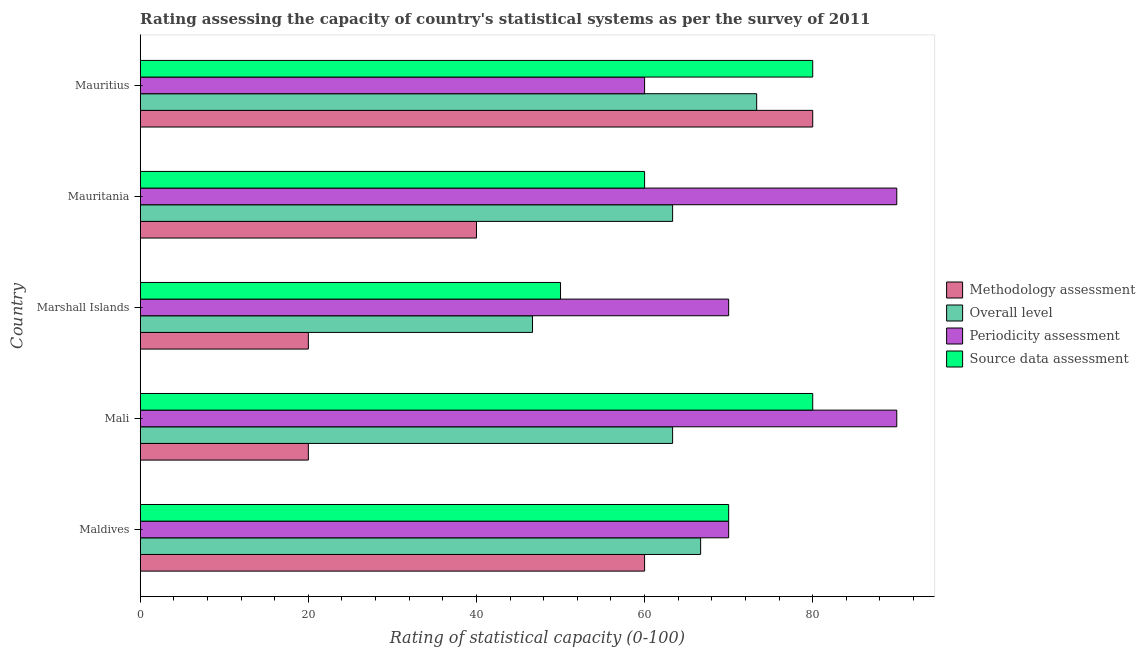How many different coloured bars are there?
Your answer should be very brief. 4. How many groups of bars are there?
Your answer should be compact. 5. Are the number of bars on each tick of the Y-axis equal?
Ensure brevity in your answer.  Yes. How many bars are there on the 4th tick from the top?
Your response must be concise. 4. How many bars are there on the 2nd tick from the bottom?
Keep it short and to the point. 4. What is the label of the 4th group of bars from the top?
Provide a short and direct response. Mali. What is the overall level rating in Maldives?
Ensure brevity in your answer.  66.67. Across all countries, what is the maximum periodicity assessment rating?
Ensure brevity in your answer.  90. Across all countries, what is the minimum periodicity assessment rating?
Your answer should be compact. 60. In which country was the overall level rating maximum?
Give a very brief answer. Mauritius. In which country was the source data assessment rating minimum?
Keep it short and to the point. Marshall Islands. What is the total source data assessment rating in the graph?
Keep it short and to the point. 340. What is the difference between the source data assessment rating in Mali and that in Mauritania?
Your answer should be compact. 20. What is the difference between the periodicity assessment rating in Mauritania and the overall level rating in Marshall Islands?
Give a very brief answer. 43.33. What is the difference between the source data assessment rating and overall level rating in Mauritania?
Ensure brevity in your answer.  -3.33. Is the difference between the methodology assessment rating in Mauritania and Mauritius greater than the difference between the overall level rating in Mauritania and Mauritius?
Offer a very short reply. No. What is the difference between the highest and the second highest source data assessment rating?
Ensure brevity in your answer.  0. What is the difference between the highest and the lowest source data assessment rating?
Give a very brief answer. 30. In how many countries, is the source data assessment rating greater than the average source data assessment rating taken over all countries?
Your answer should be very brief. 3. Is the sum of the source data assessment rating in Maldives and Mauritania greater than the maximum methodology assessment rating across all countries?
Offer a terse response. Yes. Is it the case that in every country, the sum of the overall level rating and periodicity assessment rating is greater than the sum of methodology assessment rating and source data assessment rating?
Your answer should be compact. No. What does the 2nd bar from the top in Mauritania represents?
Offer a very short reply. Periodicity assessment. What does the 2nd bar from the bottom in Maldives represents?
Give a very brief answer. Overall level. How many bars are there?
Provide a succinct answer. 20. Are all the bars in the graph horizontal?
Ensure brevity in your answer.  Yes. How many countries are there in the graph?
Your answer should be very brief. 5. What is the difference between two consecutive major ticks on the X-axis?
Provide a succinct answer. 20. Are the values on the major ticks of X-axis written in scientific E-notation?
Give a very brief answer. No. How many legend labels are there?
Ensure brevity in your answer.  4. How are the legend labels stacked?
Ensure brevity in your answer.  Vertical. What is the title of the graph?
Your answer should be compact. Rating assessing the capacity of country's statistical systems as per the survey of 2011 . Does "Primary" appear as one of the legend labels in the graph?
Offer a terse response. No. What is the label or title of the X-axis?
Make the answer very short. Rating of statistical capacity (0-100). What is the label or title of the Y-axis?
Make the answer very short. Country. What is the Rating of statistical capacity (0-100) of Methodology assessment in Maldives?
Offer a very short reply. 60. What is the Rating of statistical capacity (0-100) in Overall level in Maldives?
Your answer should be very brief. 66.67. What is the Rating of statistical capacity (0-100) in Periodicity assessment in Maldives?
Keep it short and to the point. 70. What is the Rating of statistical capacity (0-100) in Overall level in Mali?
Your answer should be very brief. 63.33. What is the Rating of statistical capacity (0-100) in Periodicity assessment in Mali?
Offer a terse response. 90. What is the Rating of statistical capacity (0-100) of Overall level in Marshall Islands?
Ensure brevity in your answer.  46.67. What is the Rating of statistical capacity (0-100) of Source data assessment in Marshall Islands?
Make the answer very short. 50. What is the Rating of statistical capacity (0-100) of Overall level in Mauritania?
Your answer should be compact. 63.33. What is the Rating of statistical capacity (0-100) of Methodology assessment in Mauritius?
Your response must be concise. 80. What is the Rating of statistical capacity (0-100) of Overall level in Mauritius?
Give a very brief answer. 73.33. What is the Rating of statistical capacity (0-100) in Periodicity assessment in Mauritius?
Your answer should be very brief. 60. What is the Rating of statistical capacity (0-100) of Source data assessment in Mauritius?
Your answer should be very brief. 80. Across all countries, what is the maximum Rating of statistical capacity (0-100) of Methodology assessment?
Give a very brief answer. 80. Across all countries, what is the maximum Rating of statistical capacity (0-100) of Overall level?
Your answer should be compact. 73.33. Across all countries, what is the minimum Rating of statistical capacity (0-100) in Overall level?
Offer a terse response. 46.67. What is the total Rating of statistical capacity (0-100) of Methodology assessment in the graph?
Give a very brief answer. 220. What is the total Rating of statistical capacity (0-100) in Overall level in the graph?
Provide a short and direct response. 313.33. What is the total Rating of statistical capacity (0-100) of Periodicity assessment in the graph?
Offer a very short reply. 380. What is the total Rating of statistical capacity (0-100) of Source data assessment in the graph?
Provide a succinct answer. 340. What is the difference between the Rating of statistical capacity (0-100) of Methodology assessment in Maldives and that in Mali?
Give a very brief answer. 40. What is the difference between the Rating of statistical capacity (0-100) of Periodicity assessment in Maldives and that in Mali?
Your answer should be very brief. -20. What is the difference between the Rating of statistical capacity (0-100) of Source data assessment in Maldives and that in Mali?
Keep it short and to the point. -10. What is the difference between the Rating of statistical capacity (0-100) of Overall level in Maldives and that in Mauritania?
Provide a short and direct response. 3.33. What is the difference between the Rating of statistical capacity (0-100) in Source data assessment in Maldives and that in Mauritania?
Your response must be concise. 10. What is the difference between the Rating of statistical capacity (0-100) in Overall level in Maldives and that in Mauritius?
Make the answer very short. -6.67. What is the difference between the Rating of statistical capacity (0-100) in Source data assessment in Maldives and that in Mauritius?
Your answer should be very brief. -10. What is the difference between the Rating of statistical capacity (0-100) in Overall level in Mali and that in Marshall Islands?
Provide a short and direct response. 16.67. What is the difference between the Rating of statistical capacity (0-100) of Source data assessment in Mali and that in Marshall Islands?
Give a very brief answer. 30. What is the difference between the Rating of statistical capacity (0-100) in Source data assessment in Mali and that in Mauritania?
Your answer should be compact. 20. What is the difference between the Rating of statistical capacity (0-100) of Methodology assessment in Mali and that in Mauritius?
Offer a very short reply. -60. What is the difference between the Rating of statistical capacity (0-100) of Overall level in Mali and that in Mauritius?
Make the answer very short. -10. What is the difference between the Rating of statistical capacity (0-100) in Methodology assessment in Marshall Islands and that in Mauritania?
Make the answer very short. -20. What is the difference between the Rating of statistical capacity (0-100) of Overall level in Marshall Islands and that in Mauritania?
Your answer should be compact. -16.67. What is the difference between the Rating of statistical capacity (0-100) of Source data assessment in Marshall Islands and that in Mauritania?
Give a very brief answer. -10. What is the difference between the Rating of statistical capacity (0-100) in Methodology assessment in Marshall Islands and that in Mauritius?
Offer a terse response. -60. What is the difference between the Rating of statistical capacity (0-100) of Overall level in Marshall Islands and that in Mauritius?
Offer a terse response. -26.67. What is the difference between the Rating of statistical capacity (0-100) of Source data assessment in Mauritania and that in Mauritius?
Your answer should be very brief. -20. What is the difference between the Rating of statistical capacity (0-100) of Methodology assessment in Maldives and the Rating of statistical capacity (0-100) of Periodicity assessment in Mali?
Keep it short and to the point. -30. What is the difference between the Rating of statistical capacity (0-100) of Methodology assessment in Maldives and the Rating of statistical capacity (0-100) of Source data assessment in Mali?
Make the answer very short. -20. What is the difference between the Rating of statistical capacity (0-100) of Overall level in Maldives and the Rating of statistical capacity (0-100) of Periodicity assessment in Mali?
Your response must be concise. -23.33. What is the difference between the Rating of statistical capacity (0-100) of Overall level in Maldives and the Rating of statistical capacity (0-100) of Source data assessment in Mali?
Your response must be concise. -13.33. What is the difference between the Rating of statistical capacity (0-100) in Methodology assessment in Maldives and the Rating of statistical capacity (0-100) in Overall level in Marshall Islands?
Your response must be concise. 13.33. What is the difference between the Rating of statistical capacity (0-100) of Methodology assessment in Maldives and the Rating of statistical capacity (0-100) of Source data assessment in Marshall Islands?
Your answer should be very brief. 10. What is the difference between the Rating of statistical capacity (0-100) in Overall level in Maldives and the Rating of statistical capacity (0-100) in Periodicity assessment in Marshall Islands?
Make the answer very short. -3.33. What is the difference between the Rating of statistical capacity (0-100) in Overall level in Maldives and the Rating of statistical capacity (0-100) in Source data assessment in Marshall Islands?
Give a very brief answer. 16.67. What is the difference between the Rating of statistical capacity (0-100) of Methodology assessment in Maldives and the Rating of statistical capacity (0-100) of Overall level in Mauritania?
Provide a succinct answer. -3.33. What is the difference between the Rating of statistical capacity (0-100) of Methodology assessment in Maldives and the Rating of statistical capacity (0-100) of Periodicity assessment in Mauritania?
Provide a short and direct response. -30. What is the difference between the Rating of statistical capacity (0-100) in Methodology assessment in Maldives and the Rating of statistical capacity (0-100) in Source data assessment in Mauritania?
Offer a terse response. 0. What is the difference between the Rating of statistical capacity (0-100) of Overall level in Maldives and the Rating of statistical capacity (0-100) of Periodicity assessment in Mauritania?
Keep it short and to the point. -23.33. What is the difference between the Rating of statistical capacity (0-100) of Periodicity assessment in Maldives and the Rating of statistical capacity (0-100) of Source data assessment in Mauritania?
Offer a terse response. 10. What is the difference between the Rating of statistical capacity (0-100) in Methodology assessment in Maldives and the Rating of statistical capacity (0-100) in Overall level in Mauritius?
Give a very brief answer. -13.33. What is the difference between the Rating of statistical capacity (0-100) in Methodology assessment in Maldives and the Rating of statistical capacity (0-100) in Periodicity assessment in Mauritius?
Provide a succinct answer. 0. What is the difference between the Rating of statistical capacity (0-100) in Overall level in Maldives and the Rating of statistical capacity (0-100) in Periodicity assessment in Mauritius?
Offer a very short reply. 6.67. What is the difference between the Rating of statistical capacity (0-100) of Overall level in Maldives and the Rating of statistical capacity (0-100) of Source data assessment in Mauritius?
Your answer should be compact. -13.33. What is the difference between the Rating of statistical capacity (0-100) in Methodology assessment in Mali and the Rating of statistical capacity (0-100) in Overall level in Marshall Islands?
Offer a terse response. -26.67. What is the difference between the Rating of statistical capacity (0-100) of Methodology assessment in Mali and the Rating of statistical capacity (0-100) of Periodicity assessment in Marshall Islands?
Provide a succinct answer. -50. What is the difference between the Rating of statistical capacity (0-100) of Methodology assessment in Mali and the Rating of statistical capacity (0-100) of Source data assessment in Marshall Islands?
Provide a succinct answer. -30. What is the difference between the Rating of statistical capacity (0-100) of Overall level in Mali and the Rating of statistical capacity (0-100) of Periodicity assessment in Marshall Islands?
Keep it short and to the point. -6.67. What is the difference between the Rating of statistical capacity (0-100) in Overall level in Mali and the Rating of statistical capacity (0-100) in Source data assessment in Marshall Islands?
Provide a short and direct response. 13.33. What is the difference between the Rating of statistical capacity (0-100) of Methodology assessment in Mali and the Rating of statistical capacity (0-100) of Overall level in Mauritania?
Your answer should be very brief. -43.33. What is the difference between the Rating of statistical capacity (0-100) of Methodology assessment in Mali and the Rating of statistical capacity (0-100) of Periodicity assessment in Mauritania?
Make the answer very short. -70. What is the difference between the Rating of statistical capacity (0-100) of Overall level in Mali and the Rating of statistical capacity (0-100) of Periodicity assessment in Mauritania?
Provide a succinct answer. -26.67. What is the difference between the Rating of statistical capacity (0-100) in Overall level in Mali and the Rating of statistical capacity (0-100) in Source data assessment in Mauritania?
Provide a succinct answer. 3.33. What is the difference between the Rating of statistical capacity (0-100) of Periodicity assessment in Mali and the Rating of statistical capacity (0-100) of Source data assessment in Mauritania?
Your answer should be very brief. 30. What is the difference between the Rating of statistical capacity (0-100) in Methodology assessment in Mali and the Rating of statistical capacity (0-100) in Overall level in Mauritius?
Keep it short and to the point. -53.33. What is the difference between the Rating of statistical capacity (0-100) in Methodology assessment in Mali and the Rating of statistical capacity (0-100) in Periodicity assessment in Mauritius?
Your answer should be compact. -40. What is the difference between the Rating of statistical capacity (0-100) in Methodology assessment in Mali and the Rating of statistical capacity (0-100) in Source data assessment in Mauritius?
Offer a terse response. -60. What is the difference between the Rating of statistical capacity (0-100) in Overall level in Mali and the Rating of statistical capacity (0-100) in Periodicity assessment in Mauritius?
Keep it short and to the point. 3.33. What is the difference between the Rating of statistical capacity (0-100) in Overall level in Mali and the Rating of statistical capacity (0-100) in Source data assessment in Mauritius?
Provide a short and direct response. -16.67. What is the difference between the Rating of statistical capacity (0-100) of Methodology assessment in Marshall Islands and the Rating of statistical capacity (0-100) of Overall level in Mauritania?
Make the answer very short. -43.33. What is the difference between the Rating of statistical capacity (0-100) of Methodology assessment in Marshall Islands and the Rating of statistical capacity (0-100) of Periodicity assessment in Mauritania?
Provide a succinct answer. -70. What is the difference between the Rating of statistical capacity (0-100) in Methodology assessment in Marshall Islands and the Rating of statistical capacity (0-100) in Source data assessment in Mauritania?
Keep it short and to the point. -40. What is the difference between the Rating of statistical capacity (0-100) of Overall level in Marshall Islands and the Rating of statistical capacity (0-100) of Periodicity assessment in Mauritania?
Keep it short and to the point. -43.33. What is the difference between the Rating of statistical capacity (0-100) in Overall level in Marshall Islands and the Rating of statistical capacity (0-100) in Source data assessment in Mauritania?
Your answer should be compact. -13.33. What is the difference between the Rating of statistical capacity (0-100) in Periodicity assessment in Marshall Islands and the Rating of statistical capacity (0-100) in Source data assessment in Mauritania?
Offer a very short reply. 10. What is the difference between the Rating of statistical capacity (0-100) of Methodology assessment in Marshall Islands and the Rating of statistical capacity (0-100) of Overall level in Mauritius?
Your answer should be very brief. -53.33. What is the difference between the Rating of statistical capacity (0-100) in Methodology assessment in Marshall Islands and the Rating of statistical capacity (0-100) in Source data assessment in Mauritius?
Provide a short and direct response. -60. What is the difference between the Rating of statistical capacity (0-100) in Overall level in Marshall Islands and the Rating of statistical capacity (0-100) in Periodicity assessment in Mauritius?
Your answer should be compact. -13.33. What is the difference between the Rating of statistical capacity (0-100) in Overall level in Marshall Islands and the Rating of statistical capacity (0-100) in Source data assessment in Mauritius?
Provide a short and direct response. -33.33. What is the difference between the Rating of statistical capacity (0-100) in Methodology assessment in Mauritania and the Rating of statistical capacity (0-100) in Overall level in Mauritius?
Your response must be concise. -33.33. What is the difference between the Rating of statistical capacity (0-100) of Overall level in Mauritania and the Rating of statistical capacity (0-100) of Source data assessment in Mauritius?
Ensure brevity in your answer.  -16.67. What is the difference between the Rating of statistical capacity (0-100) of Periodicity assessment in Mauritania and the Rating of statistical capacity (0-100) of Source data assessment in Mauritius?
Provide a succinct answer. 10. What is the average Rating of statistical capacity (0-100) of Overall level per country?
Provide a short and direct response. 62.67. What is the difference between the Rating of statistical capacity (0-100) of Methodology assessment and Rating of statistical capacity (0-100) of Overall level in Maldives?
Give a very brief answer. -6.67. What is the difference between the Rating of statistical capacity (0-100) of Periodicity assessment and Rating of statistical capacity (0-100) of Source data assessment in Maldives?
Make the answer very short. 0. What is the difference between the Rating of statistical capacity (0-100) in Methodology assessment and Rating of statistical capacity (0-100) in Overall level in Mali?
Keep it short and to the point. -43.33. What is the difference between the Rating of statistical capacity (0-100) in Methodology assessment and Rating of statistical capacity (0-100) in Periodicity assessment in Mali?
Ensure brevity in your answer.  -70. What is the difference between the Rating of statistical capacity (0-100) of Methodology assessment and Rating of statistical capacity (0-100) of Source data assessment in Mali?
Provide a short and direct response. -60. What is the difference between the Rating of statistical capacity (0-100) of Overall level and Rating of statistical capacity (0-100) of Periodicity assessment in Mali?
Keep it short and to the point. -26.67. What is the difference between the Rating of statistical capacity (0-100) of Overall level and Rating of statistical capacity (0-100) of Source data assessment in Mali?
Make the answer very short. -16.67. What is the difference between the Rating of statistical capacity (0-100) of Methodology assessment and Rating of statistical capacity (0-100) of Overall level in Marshall Islands?
Your answer should be very brief. -26.67. What is the difference between the Rating of statistical capacity (0-100) in Methodology assessment and Rating of statistical capacity (0-100) in Periodicity assessment in Marshall Islands?
Your answer should be compact. -50. What is the difference between the Rating of statistical capacity (0-100) in Methodology assessment and Rating of statistical capacity (0-100) in Source data assessment in Marshall Islands?
Give a very brief answer. -30. What is the difference between the Rating of statistical capacity (0-100) of Overall level and Rating of statistical capacity (0-100) of Periodicity assessment in Marshall Islands?
Your answer should be compact. -23.33. What is the difference between the Rating of statistical capacity (0-100) in Overall level and Rating of statistical capacity (0-100) in Source data assessment in Marshall Islands?
Give a very brief answer. -3.33. What is the difference between the Rating of statistical capacity (0-100) in Methodology assessment and Rating of statistical capacity (0-100) in Overall level in Mauritania?
Your answer should be compact. -23.33. What is the difference between the Rating of statistical capacity (0-100) in Methodology assessment and Rating of statistical capacity (0-100) in Periodicity assessment in Mauritania?
Provide a succinct answer. -50. What is the difference between the Rating of statistical capacity (0-100) in Overall level and Rating of statistical capacity (0-100) in Periodicity assessment in Mauritania?
Make the answer very short. -26.67. What is the difference between the Rating of statistical capacity (0-100) of Methodology assessment and Rating of statistical capacity (0-100) of Overall level in Mauritius?
Provide a succinct answer. 6.67. What is the difference between the Rating of statistical capacity (0-100) of Methodology assessment and Rating of statistical capacity (0-100) of Periodicity assessment in Mauritius?
Your answer should be compact. 20. What is the difference between the Rating of statistical capacity (0-100) in Methodology assessment and Rating of statistical capacity (0-100) in Source data assessment in Mauritius?
Your answer should be compact. 0. What is the difference between the Rating of statistical capacity (0-100) of Overall level and Rating of statistical capacity (0-100) of Periodicity assessment in Mauritius?
Provide a succinct answer. 13.33. What is the difference between the Rating of statistical capacity (0-100) in Overall level and Rating of statistical capacity (0-100) in Source data assessment in Mauritius?
Offer a terse response. -6.67. What is the difference between the Rating of statistical capacity (0-100) of Periodicity assessment and Rating of statistical capacity (0-100) of Source data assessment in Mauritius?
Your response must be concise. -20. What is the ratio of the Rating of statistical capacity (0-100) of Overall level in Maldives to that in Mali?
Offer a very short reply. 1.05. What is the ratio of the Rating of statistical capacity (0-100) of Methodology assessment in Maldives to that in Marshall Islands?
Make the answer very short. 3. What is the ratio of the Rating of statistical capacity (0-100) in Overall level in Maldives to that in Marshall Islands?
Your answer should be very brief. 1.43. What is the ratio of the Rating of statistical capacity (0-100) in Periodicity assessment in Maldives to that in Marshall Islands?
Give a very brief answer. 1. What is the ratio of the Rating of statistical capacity (0-100) in Overall level in Maldives to that in Mauritania?
Give a very brief answer. 1.05. What is the ratio of the Rating of statistical capacity (0-100) of Methodology assessment in Maldives to that in Mauritius?
Provide a succinct answer. 0.75. What is the ratio of the Rating of statistical capacity (0-100) in Periodicity assessment in Maldives to that in Mauritius?
Make the answer very short. 1.17. What is the ratio of the Rating of statistical capacity (0-100) of Source data assessment in Maldives to that in Mauritius?
Give a very brief answer. 0.88. What is the ratio of the Rating of statistical capacity (0-100) of Overall level in Mali to that in Marshall Islands?
Provide a short and direct response. 1.36. What is the ratio of the Rating of statistical capacity (0-100) in Source data assessment in Mali to that in Marshall Islands?
Your answer should be compact. 1.6. What is the ratio of the Rating of statistical capacity (0-100) in Source data assessment in Mali to that in Mauritania?
Keep it short and to the point. 1.33. What is the ratio of the Rating of statistical capacity (0-100) of Methodology assessment in Mali to that in Mauritius?
Your answer should be very brief. 0.25. What is the ratio of the Rating of statistical capacity (0-100) in Overall level in Mali to that in Mauritius?
Provide a short and direct response. 0.86. What is the ratio of the Rating of statistical capacity (0-100) of Source data assessment in Mali to that in Mauritius?
Keep it short and to the point. 1. What is the ratio of the Rating of statistical capacity (0-100) of Overall level in Marshall Islands to that in Mauritania?
Make the answer very short. 0.74. What is the ratio of the Rating of statistical capacity (0-100) in Source data assessment in Marshall Islands to that in Mauritania?
Ensure brevity in your answer.  0.83. What is the ratio of the Rating of statistical capacity (0-100) of Overall level in Marshall Islands to that in Mauritius?
Your answer should be very brief. 0.64. What is the ratio of the Rating of statistical capacity (0-100) of Source data assessment in Marshall Islands to that in Mauritius?
Provide a short and direct response. 0.62. What is the ratio of the Rating of statistical capacity (0-100) in Overall level in Mauritania to that in Mauritius?
Offer a very short reply. 0.86. What is the ratio of the Rating of statistical capacity (0-100) in Source data assessment in Mauritania to that in Mauritius?
Your answer should be very brief. 0.75. What is the difference between the highest and the second highest Rating of statistical capacity (0-100) of Methodology assessment?
Your answer should be compact. 20. What is the difference between the highest and the lowest Rating of statistical capacity (0-100) in Overall level?
Offer a very short reply. 26.67. What is the difference between the highest and the lowest Rating of statistical capacity (0-100) of Source data assessment?
Your answer should be compact. 30. 